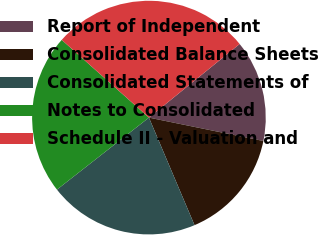<chart> <loc_0><loc_0><loc_500><loc_500><pie_chart><fcel>Report of Independent<fcel>Consolidated Balance Sheets<fcel>Consolidated Statements of<fcel>Notes to Consolidated<fcel>Schedule II - Valuation and<nl><fcel>14.06%<fcel>15.41%<fcel>20.81%<fcel>22.16%<fcel>27.56%<nl></chart> 